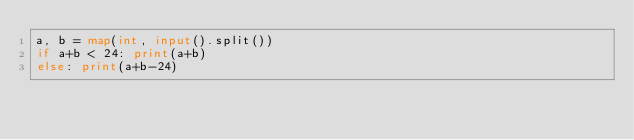Convert code to text. <code><loc_0><loc_0><loc_500><loc_500><_Python_>a, b = map(int, input().split())
if a+b < 24: print(a+b)
else: print(a+b-24)
</code> 